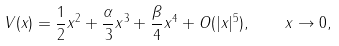Convert formula to latex. <formula><loc_0><loc_0><loc_500><loc_500>V ( x ) = \frac { 1 } { 2 } x ^ { 2 } + \frac { \alpha } { 3 } x ^ { 3 } + \frac { \beta } { 4 } x ^ { 4 } + O ( | x | ^ { 5 } ) , \quad x \rightarrow 0 ,</formula> 